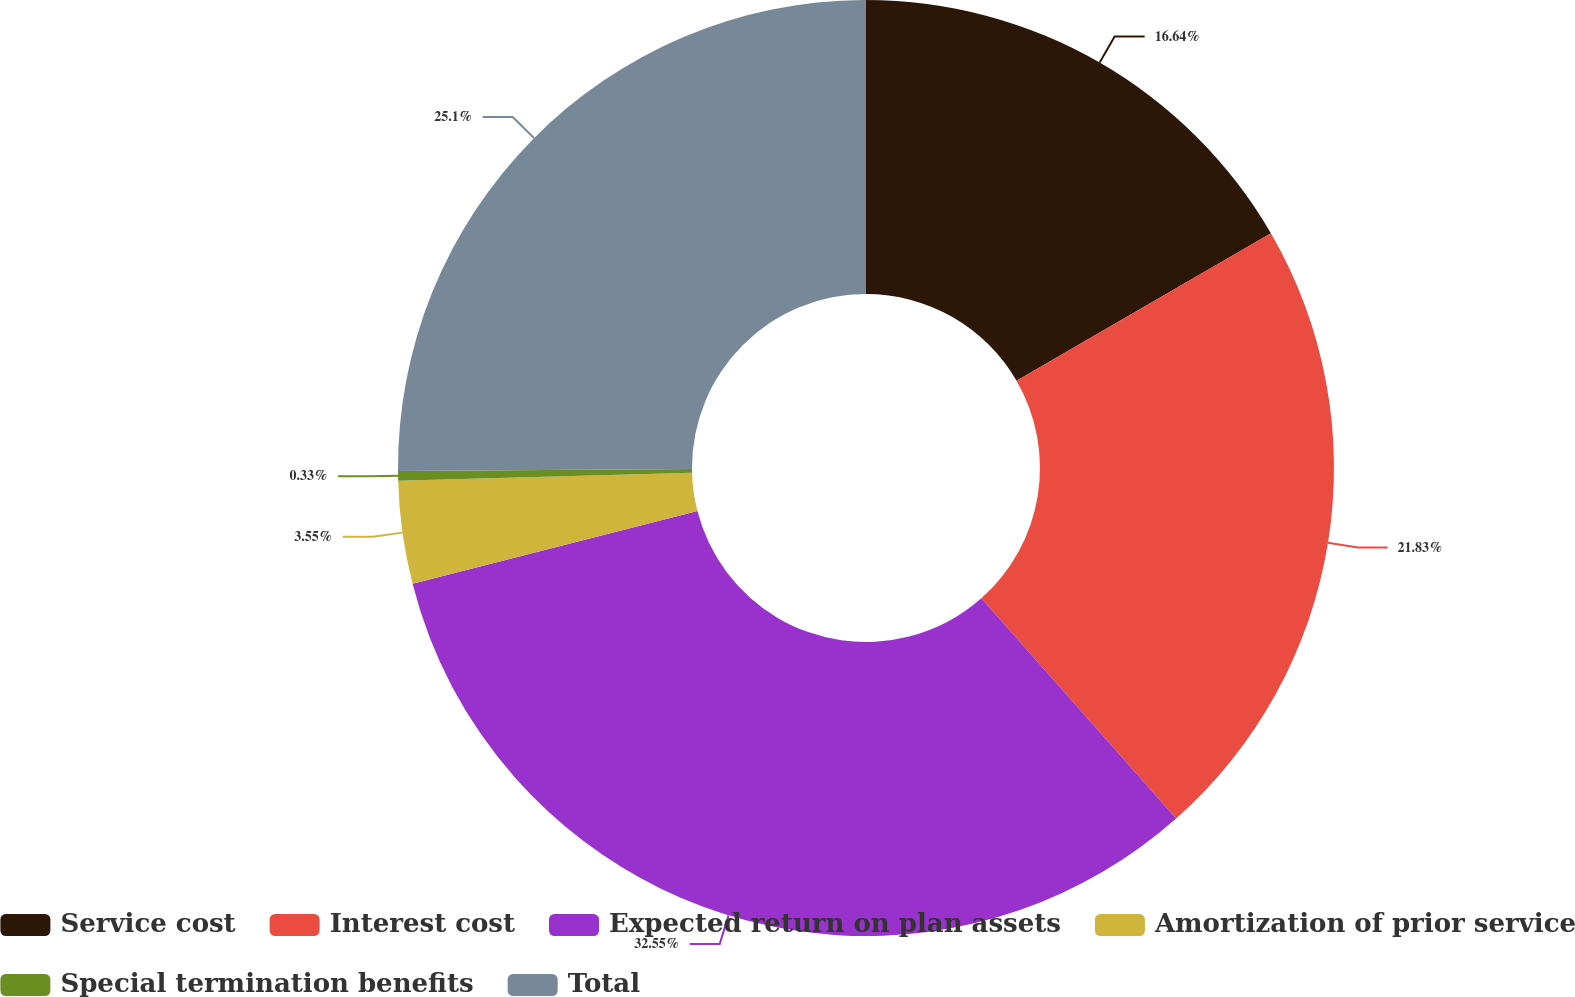Convert chart to OTSL. <chart><loc_0><loc_0><loc_500><loc_500><pie_chart><fcel>Service cost<fcel>Interest cost<fcel>Expected return on plan assets<fcel>Amortization of prior service<fcel>Special termination benefits<fcel>Total<nl><fcel>16.64%<fcel>21.83%<fcel>32.55%<fcel>3.55%<fcel>0.33%<fcel>25.1%<nl></chart> 